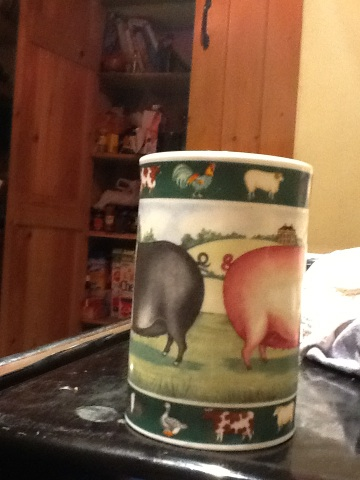What animals are depicted on the cup? The cup features two pigs prominently on its design. One pig is black, and the other is pink. Additionally, there are images of other farm animals like a rooster, a sheep, and some smaller animals. Can you describe the setting depicted on the cup? Certainly! The setting on the cup appears to be a pastoral farm scene. It includes a grassy field where the black and pink pigs are standing, presumably on a farm. The background shows some farm structures and other animals, contributing to a serene, rural atmosphere. Imagine a whimsical story involving the animals on this cup. Once upon a time on a magical farm, the black pig and the pink pig were the best of friends. Every morning, they would race across the meadow to see who could reach the apple tree first. One day, they discovered a sparkling pond that led to an enchanted forest. Together, they made new friends like a talkative sheep and a wise rooster who told of hidden treasures. Adventures awaited them each day as they explored new corners of their whimsical world, learning valuable lessons about friendship and teamwork. 